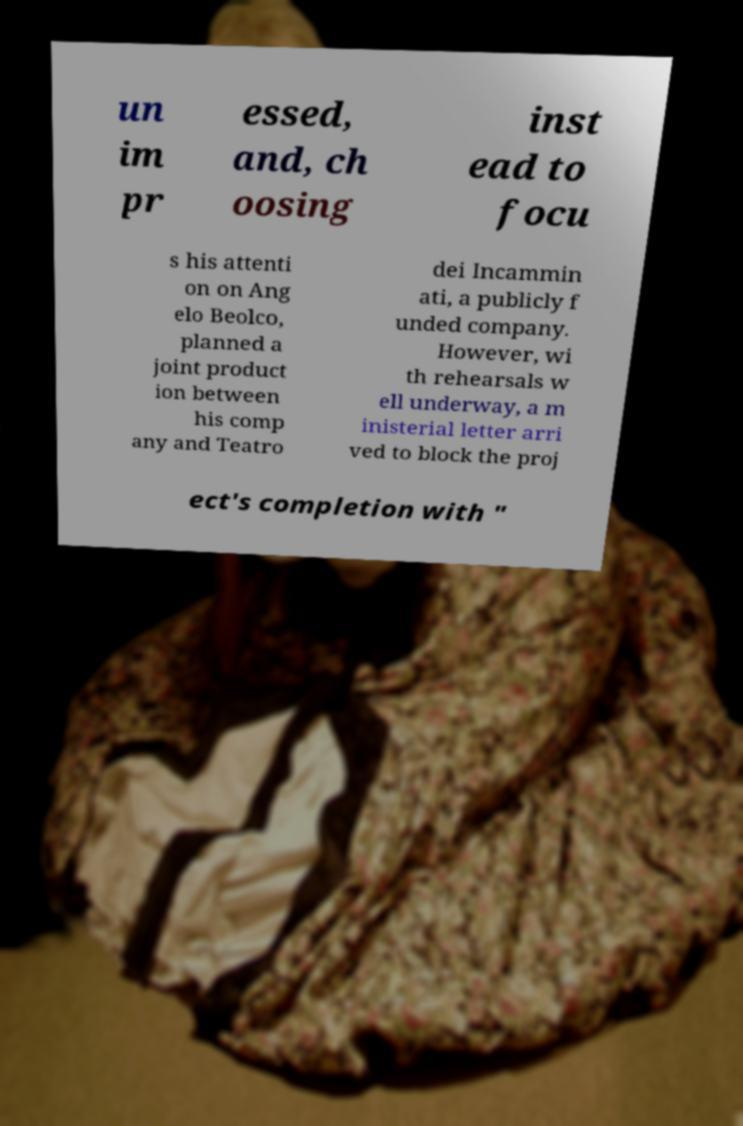What messages or text are displayed in this image? I need them in a readable, typed format. un im pr essed, and, ch oosing inst ead to focu s his attenti on on Ang elo Beolco, planned a joint product ion between his comp any and Teatro dei Incammin ati, a publicly f unded company. However, wi th rehearsals w ell underway, a m inisterial letter arri ved to block the proj ect's completion with " 